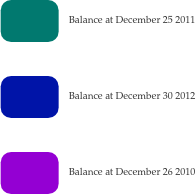<chart> <loc_0><loc_0><loc_500><loc_500><pie_chart><fcel>Balance at December 25 2011<fcel>Balance at December 30 2012<fcel>Balance at December 26 2010<nl><fcel>33.33%<fcel>33.34%<fcel>33.33%<nl></chart> 